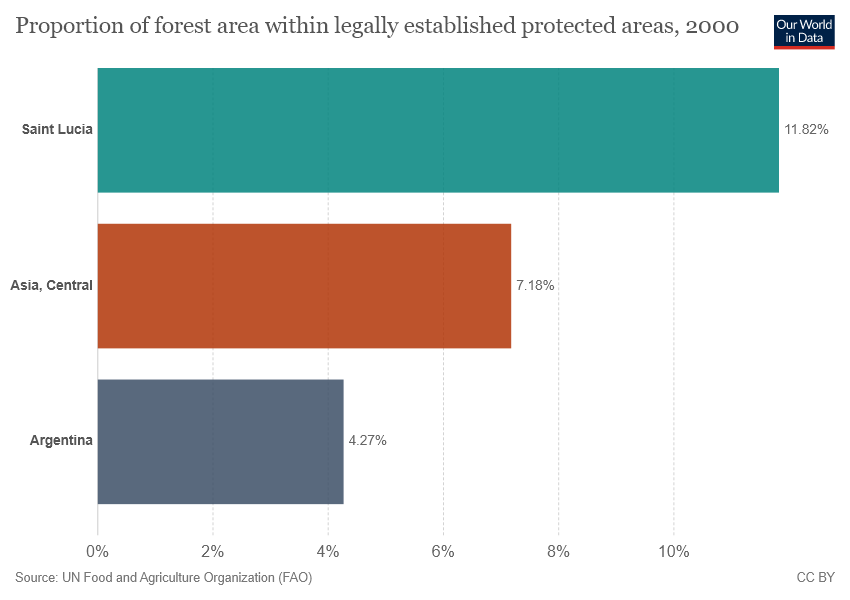Draw attention to some important aspects in this diagram. The highest value in the chart is 0.1182. The ratio of Asia Central to Saint Lucia is 7 to 18, with 11.82 in between. 